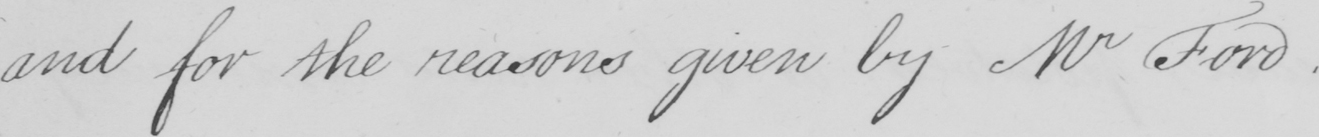What is written in this line of handwriting? and for the reasons given by Mr Ford . 